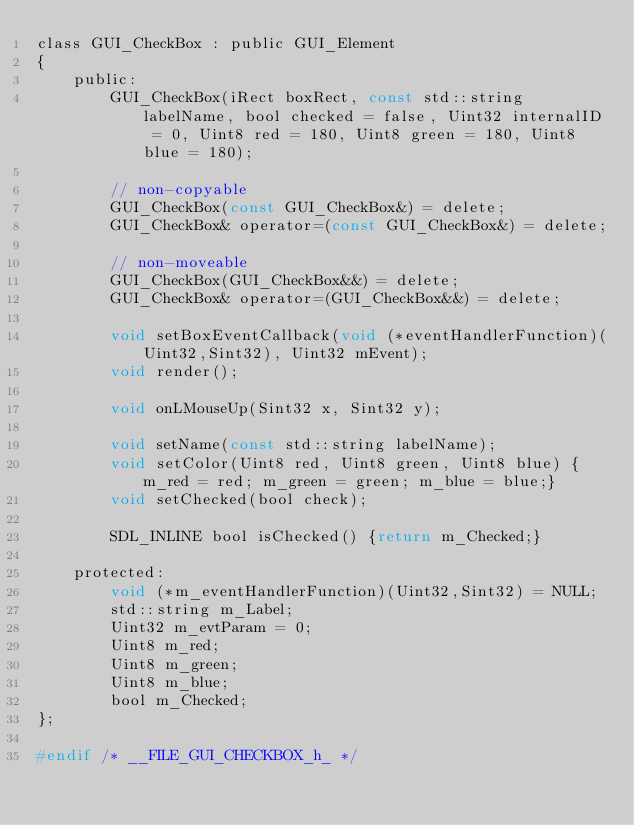<code> <loc_0><loc_0><loc_500><loc_500><_C_>class GUI_CheckBox : public GUI_Element
{
	public:
		GUI_CheckBox(iRect boxRect, const std::string labelName, bool checked = false, Uint32 internalID = 0, Uint8 red = 180, Uint8 green = 180, Uint8 blue = 180);

		// non-copyable
		GUI_CheckBox(const GUI_CheckBox&) = delete;
		GUI_CheckBox& operator=(const GUI_CheckBox&) = delete;

		// non-moveable
		GUI_CheckBox(GUI_CheckBox&&) = delete;
		GUI_CheckBox& operator=(GUI_CheckBox&&) = delete;

		void setBoxEventCallback(void (*eventHandlerFunction)(Uint32,Sint32), Uint32 mEvent);
		void render();

		void onLMouseUp(Sint32 x, Sint32 y);

		void setName(const std::string labelName);
		void setColor(Uint8 red, Uint8 green, Uint8 blue) {m_red = red; m_green = green; m_blue = blue;}
		void setChecked(bool check);

		SDL_INLINE bool isChecked() {return m_Checked;}

	protected:
		void (*m_eventHandlerFunction)(Uint32,Sint32) = NULL;
		std::string m_Label;
		Uint32 m_evtParam = 0;
		Uint8 m_red;
		Uint8 m_green;
		Uint8 m_blue;
		bool m_Checked;
};

#endif /* __FILE_GUI_CHECKBOX_h_ */
</code> 